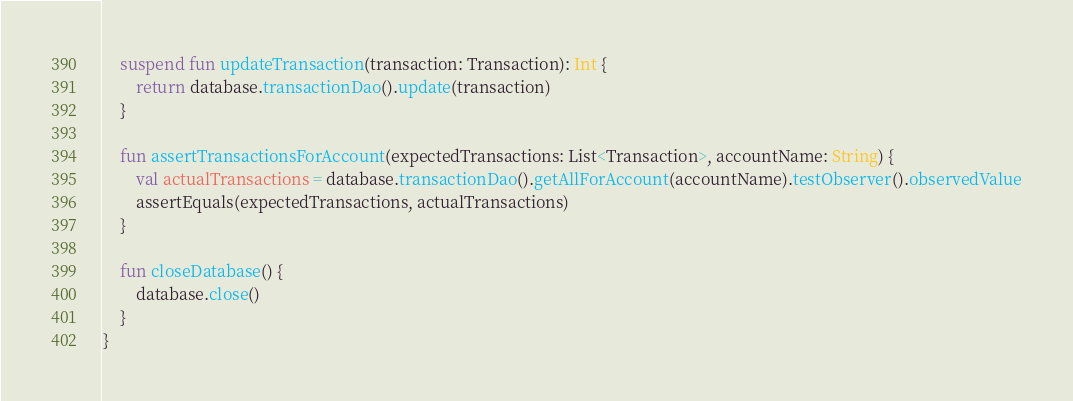<code> <loc_0><loc_0><loc_500><loc_500><_Kotlin_>    suspend fun updateTransaction(transaction: Transaction): Int {
        return database.transactionDao().update(transaction)
    }

    fun assertTransactionsForAccount(expectedTransactions: List<Transaction>, accountName: String) {
        val actualTransactions = database.transactionDao().getAllForAccount(accountName).testObserver().observedValue
        assertEquals(expectedTransactions, actualTransactions)
    }

    fun closeDatabase() {
        database.close()
    }
}</code> 